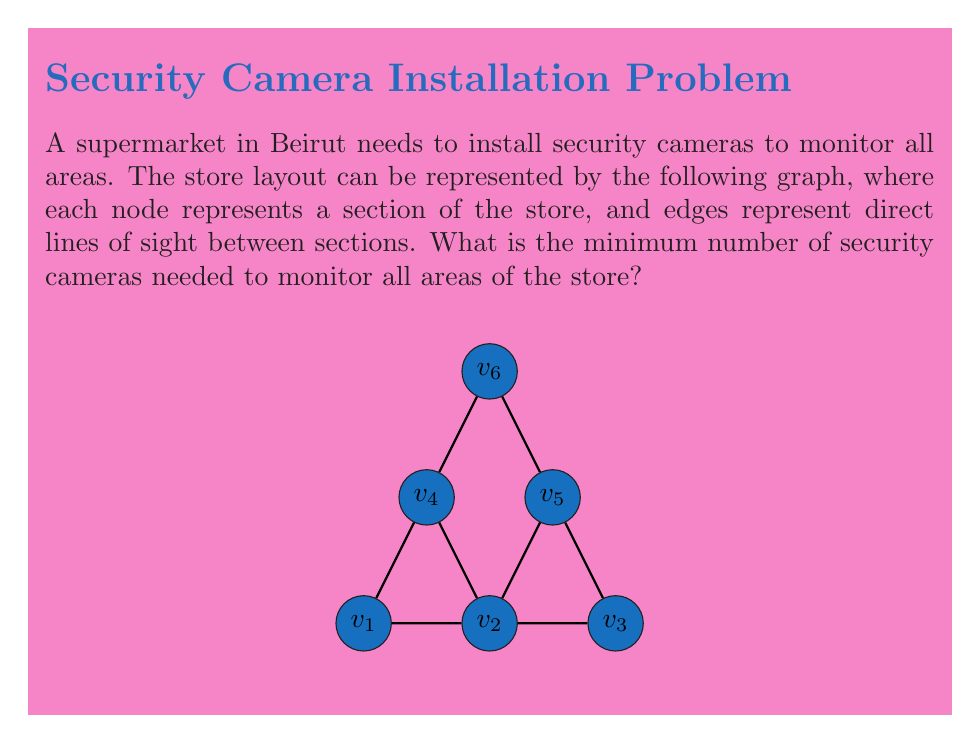Solve this math problem. To solve this problem, we need to find the minimum dominating set of the graph, which represents the minimum number of security cameras needed to cover all areas.

Step 1: Understand the concept of a dominating set.
A dominating set is a subset of nodes in a graph such that every node in the graph is either in the set or adjacent to a node in the set.

Step 2: Analyze the graph structure.
The graph has 6 nodes ($$v_1$$ to $$v_6$$) representing different sections of the store.

Step 3: Identify key nodes.
Nodes $$v_2$$ and $$v_5$$ have the highest degree (number of connections), making them good candidates for the dominating set.

Step 4: Check coverage.
- Placing a camera at $$v_2$$ covers $$v_1$$, $$v_2$$, $$v_3$$, $$v_4$$, and $$v_5$$.
- Placing a camera at $$v_5$$ covers $$v_2$$, $$v_3$$, $$v_4$$, $$v_5$$, and $$v_6$$.

Step 5: Verify complete coverage.
The set $$\{v_2, v_5\}$$ covers all nodes in the graph.

Step 6: Check for smaller dominating sets.
There is no single node that can cover all other nodes, so this is the minimum dominating set.

Therefore, the minimum number of security cameras needed is 2, placed at positions corresponding to nodes $$v_2$$ and $$v_5$$ in the graph.
Answer: 2 